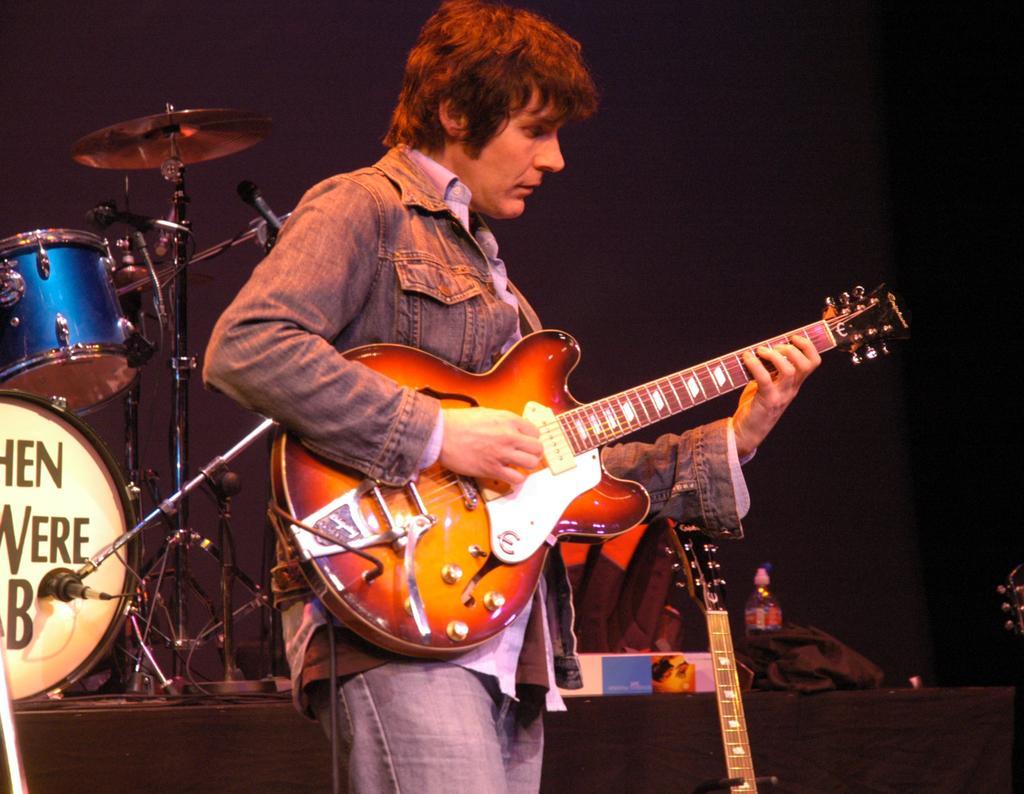Describe this image in one or two sentences. In this image there is a person playing guitar, beside him there is another guitar, behind him there is a other musical instrument and a few other objects. The background is dark. 